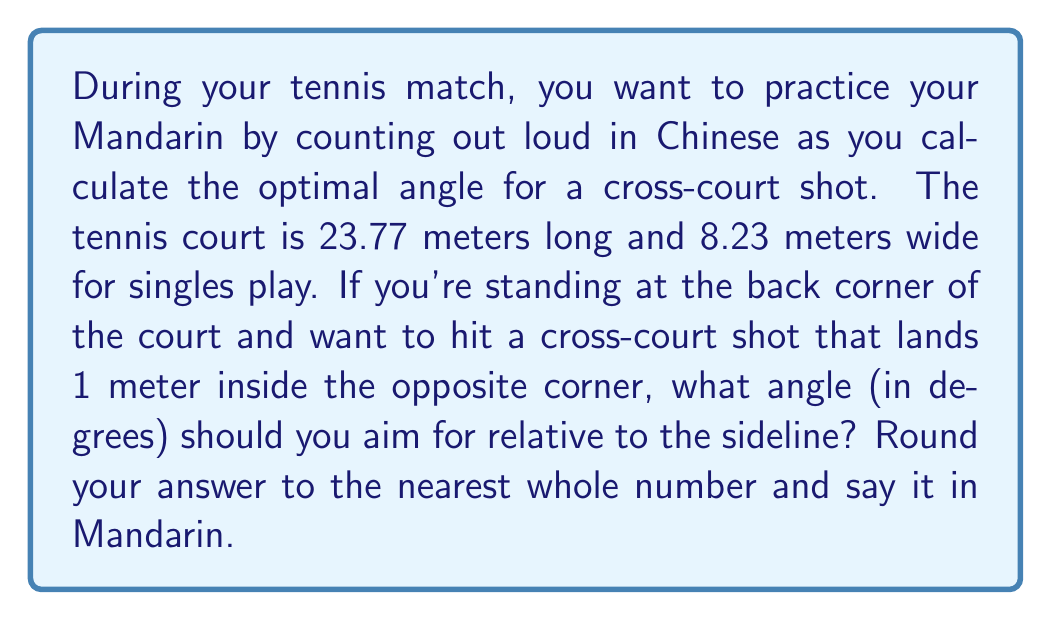Could you help me with this problem? Let's approach this step-by-step:

1) First, we need to visualize the court and the shot. We can represent this as a right triangle:

[asy]
unitsize(0.2cm);
draw((0,0)--(23.77,0)--(23.77,8.23)--(0,8.23)--cycle);
draw((0,0)--(23.77,7.23),red);
label("23.77m", (11.885,-2), S);
label("8.23m", (25.77,4.115), E);
label("θ", (2,1), NW);
label("x", (11.885,3.615), N);
[/asy]

2) The length of the court (23.77m) forms the adjacent side of our triangle.

3) The width of the court minus 1 meter (8.23m - 1m = 7.23m) forms the opposite side.

4) We can use the tangent function to find the angle:

   $$\tan(\theta) = \frac{\text{opposite}}{\text{adjacent}} = \frac{7.23}{23.77}$$

5) To solve for θ, we use the inverse tangent (arctan or tan^(-1)):

   $$\theta = \tan^{-1}(\frac{7.23}{23.77})$$

6) Using a calculator:

   $$\theta = \tan^{-1}(0.3042) \approx 16.91^\circ$$

7) Rounding to the nearest whole number:

   $$\theta \approx 17^\circ$$

8) In Mandarin, 17 is pronounced "shí qī".
Answer: 17° (shí qī) 